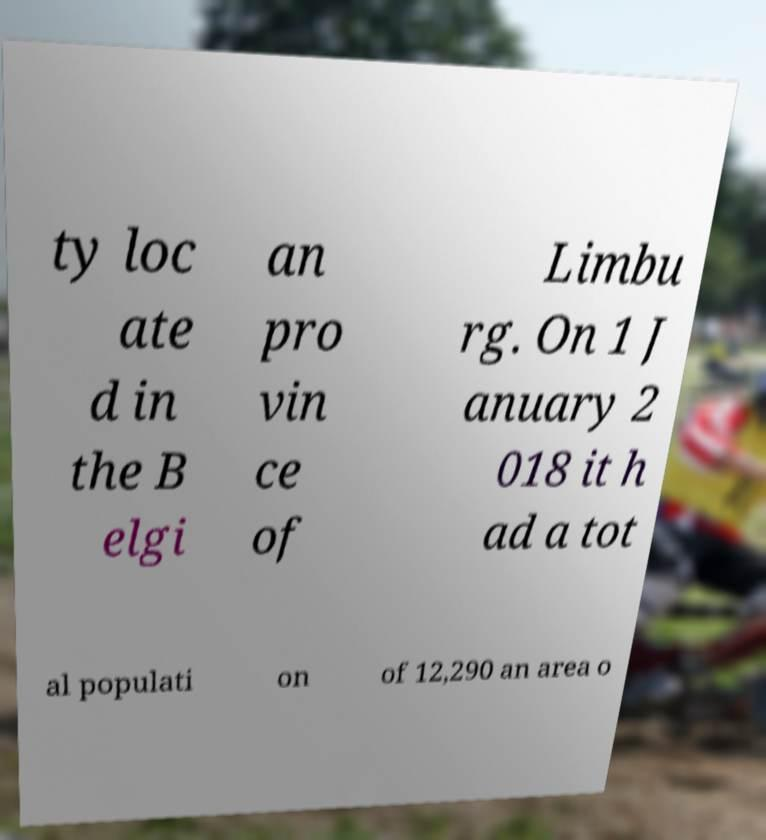What messages or text are displayed in this image? I need them in a readable, typed format. ty loc ate d in the B elgi an pro vin ce of Limbu rg. On 1 J anuary 2 018 it h ad a tot al populati on of 12,290 an area o 